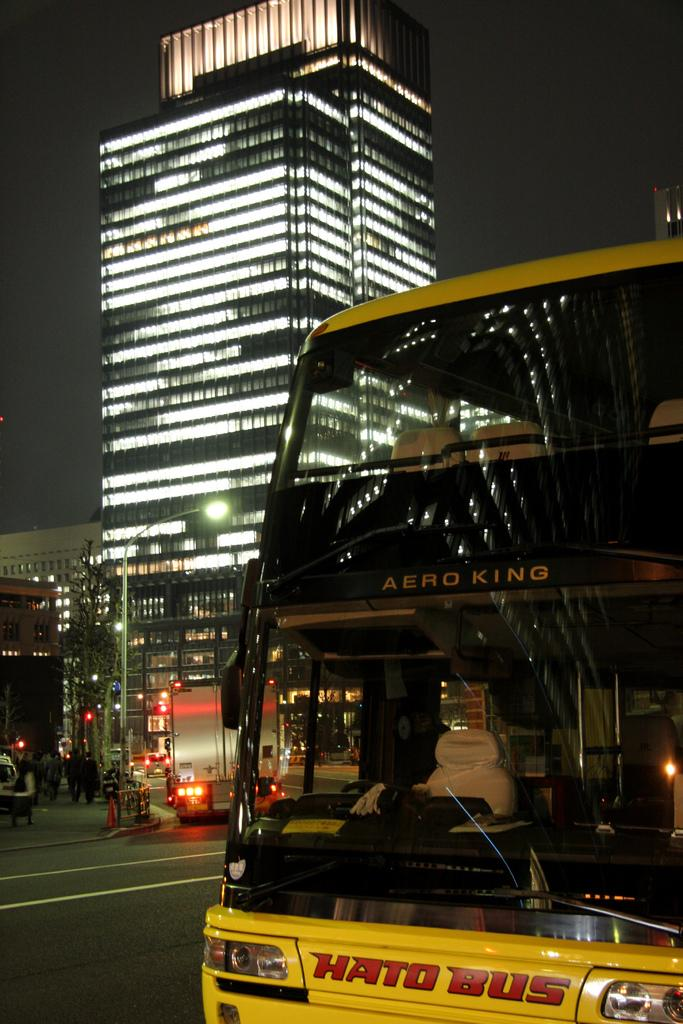<image>
Relay a brief, clear account of the picture shown. A yellow Hato Bus made by Aero King on a city street at night. 